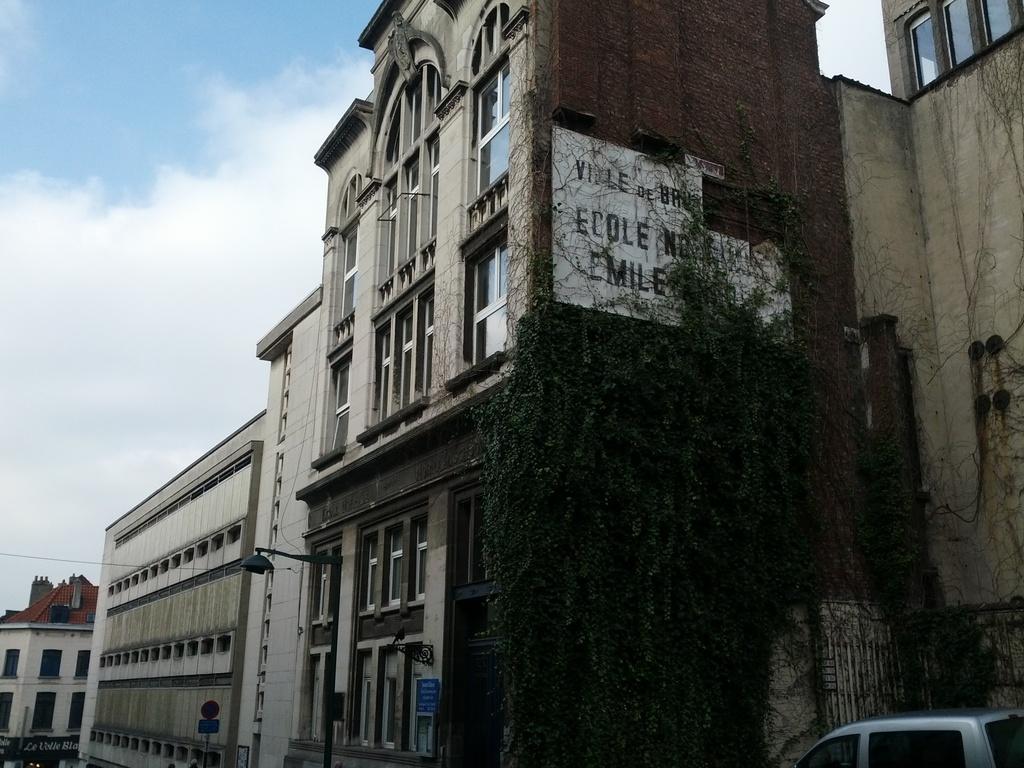Could you give a brief overview of what you see in this image? In the middle of the image there is a building with windows, walls and to the walls there are creepers. In front of the walls there are poles with sign boards. To the right bottom corner of the image there is a car. And to the left top of the image there is a sky with clouds. And to the bottom left of the image there is a building with a roof, windows and walls.  